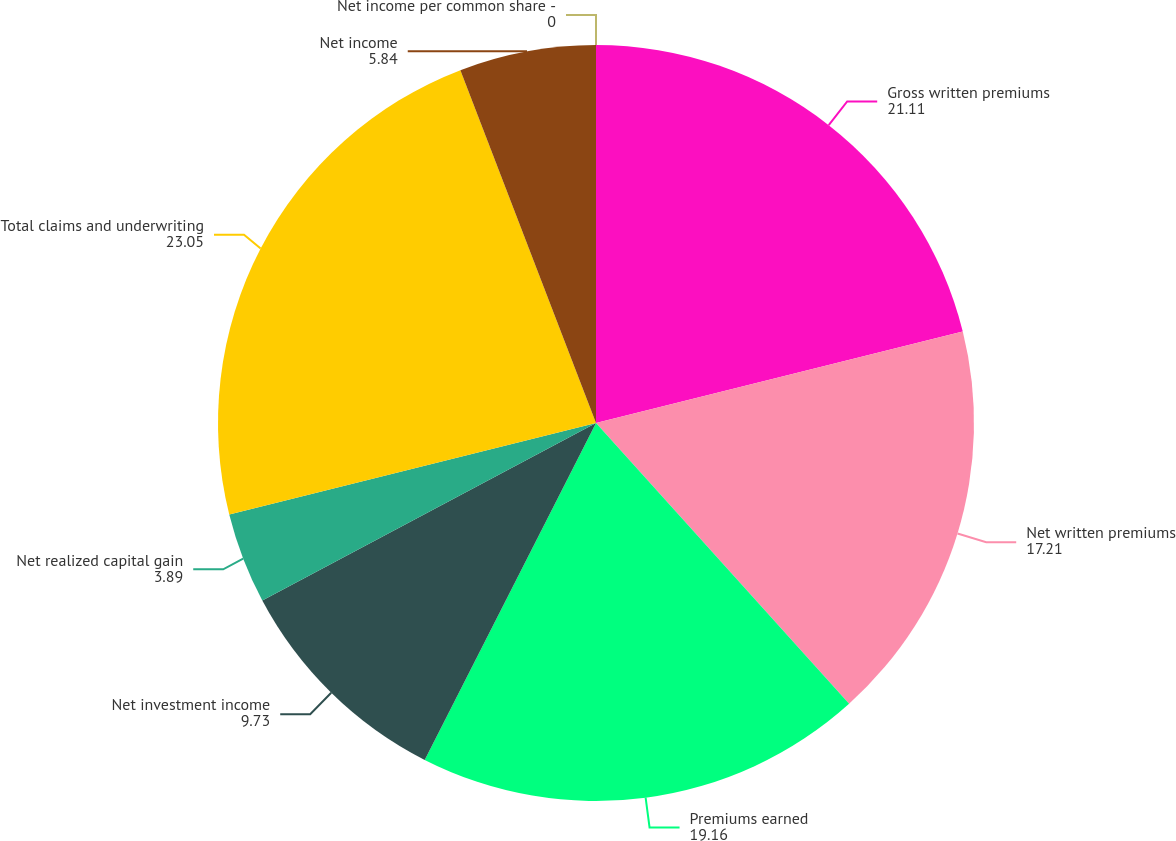<chart> <loc_0><loc_0><loc_500><loc_500><pie_chart><fcel>Gross written premiums<fcel>Net written premiums<fcel>Premiums earned<fcel>Net investment income<fcel>Net realized capital gain<fcel>Total claims and underwriting<fcel>Net income<fcel>Net income per common share -<nl><fcel>21.11%<fcel>17.21%<fcel>19.16%<fcel>9.73%<fcel>3.89%<fcel>23.05%<fcel>5.84%<fcel>0.0%<nl></chart> 